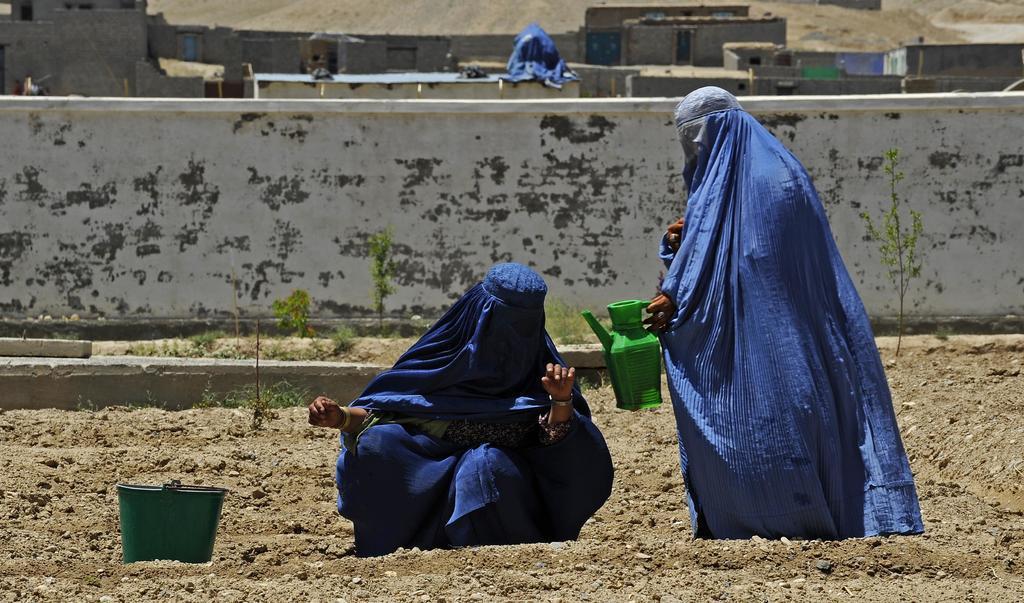Describe this image in one or two sentences. In the foreground I can see a person is holding a mug in hand and another person is in squat position on the ground and a bucket. In the background I can see grass, fence, plants, houses, doors and so on. This image is taken may be during a day. 